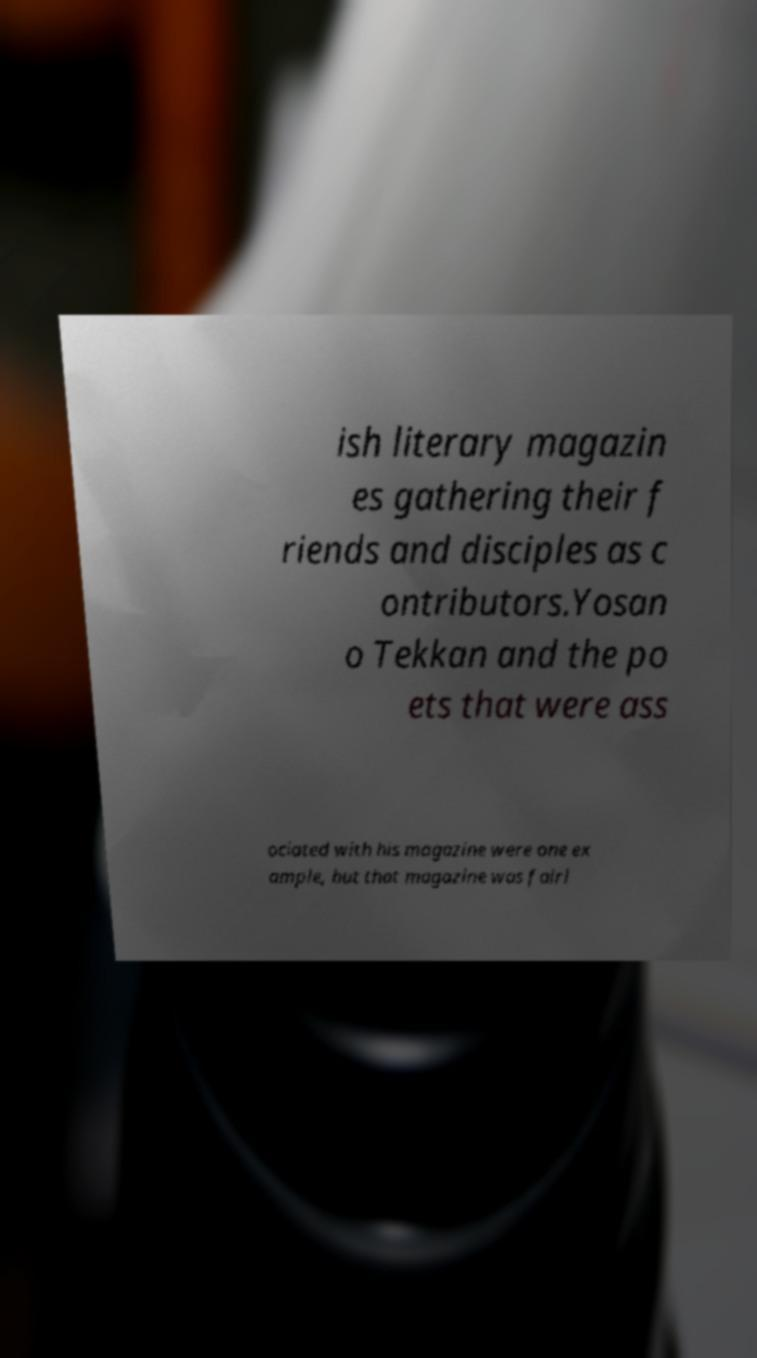Can you read and provide the text displayed in the image?This photo seems to have some interesting text. Can you extract and type it out for me? ish literary magazin es gathering their f riends and disciples as c ontributors.Yosan o Tekkan and the po ets that were ass ociated with his magazine were one ex ample, but that magazine was fairl 